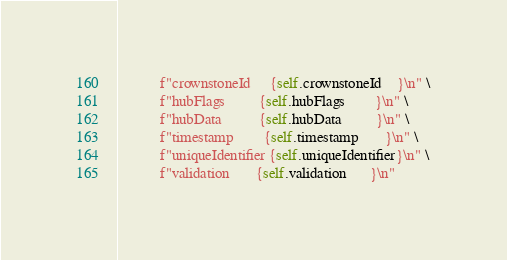<code> <loc_0><loc_0><loc_500><loc_500><_Python_>           f"crownstoneId     {self.crownstoneId    }\n" \
           f"hubFlags         {self.hubFlags        }\n" \
           f"hubData          {self.hubData         }\n" \
           f"timestamp        {self.timestamp       }\n" \
           f"uniqueIdentifier {self.uniqueIdentifier}\n" \
           f"validation       {self.validation      }\n"
</code> 